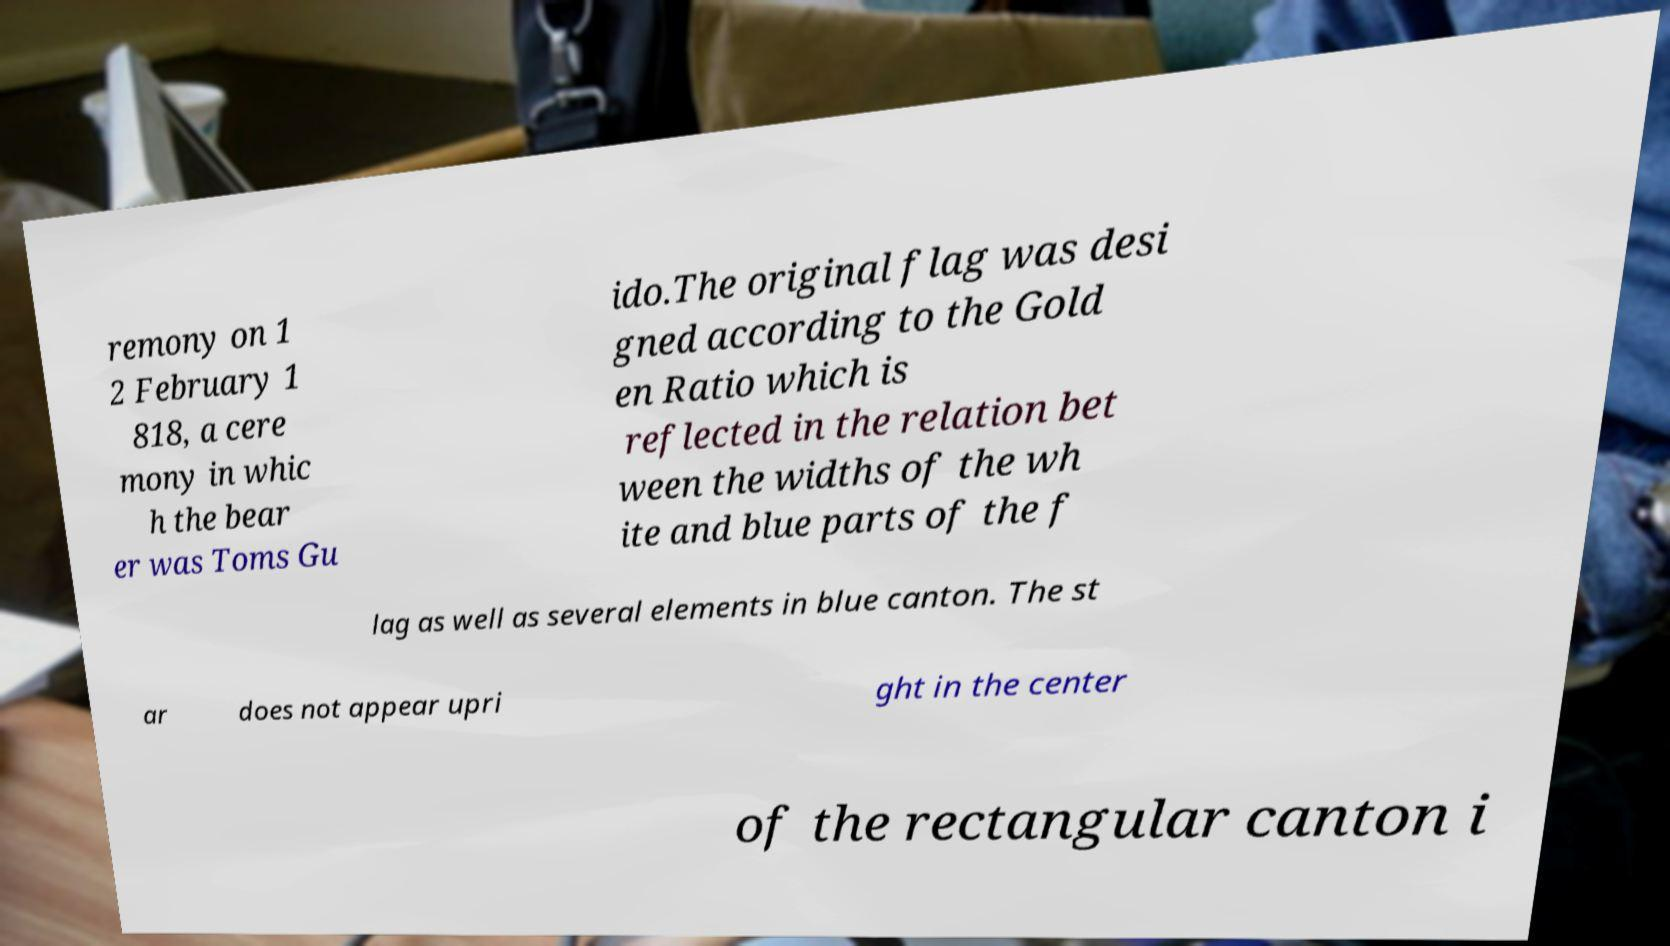Please read and relay the text visible in this image. What does it say? remony on 1 2 February 1 818, a cere mony in whic h the bear er was Toms Gu ido.The original flag was desi gned according to the Gold en Ratio which is reflected in the relation bet ween the widths of the wh ite and blue parts of the f lag as well as several elements in blue canton. The st ar does not appear upri ght in the center of the rectangular canton i 